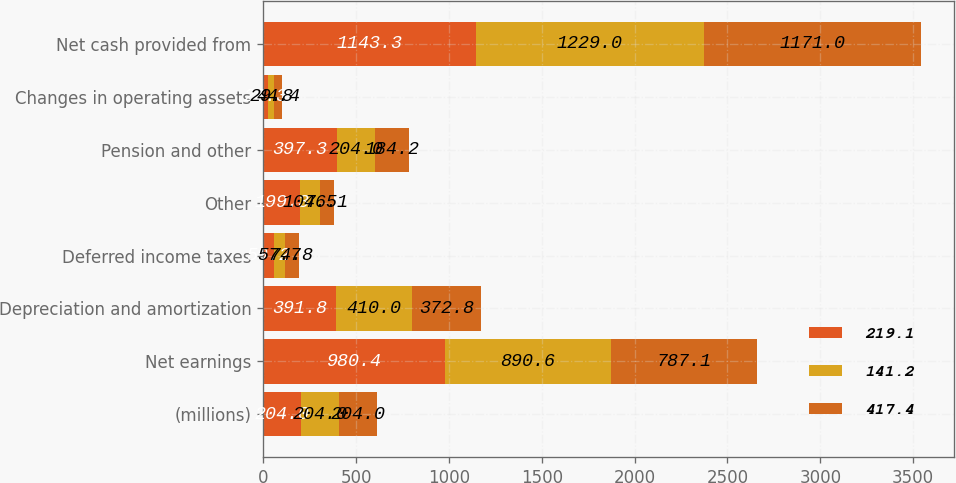Convert chart. <chart><loc_0><loc_0><loc_500><loc_500><stacked_bar_chart><ecel><fcel>(millions)<fcel>Net earnings<fcel>Depreciation and amortization<fcel>Deferred income taxes<fcel>Other<fcel>Pension and other<fcel>Changes in operating assets<fcel>Net cash provided from<nl><fcel>219.1<fcel>204<fcel>980.4<fcel>391.8<fcel>59.2<fcel>199.3<fcel>397.3<fcel>28.3<fcel>1143.3<nl><fcel>141.2<fcel>204<fcel>890.6<fcel>410<fcel>57.7<fcel>104.5<fcel>204<fcel>29.8<fcel>1229<nl><fcel>417.4<fcel>204<fcel>787.1<fcel>372.8<fcel>74.8<fcel>76.1<fcel>184.2<fcel>44.4<fcel>1171<nl></chart> 